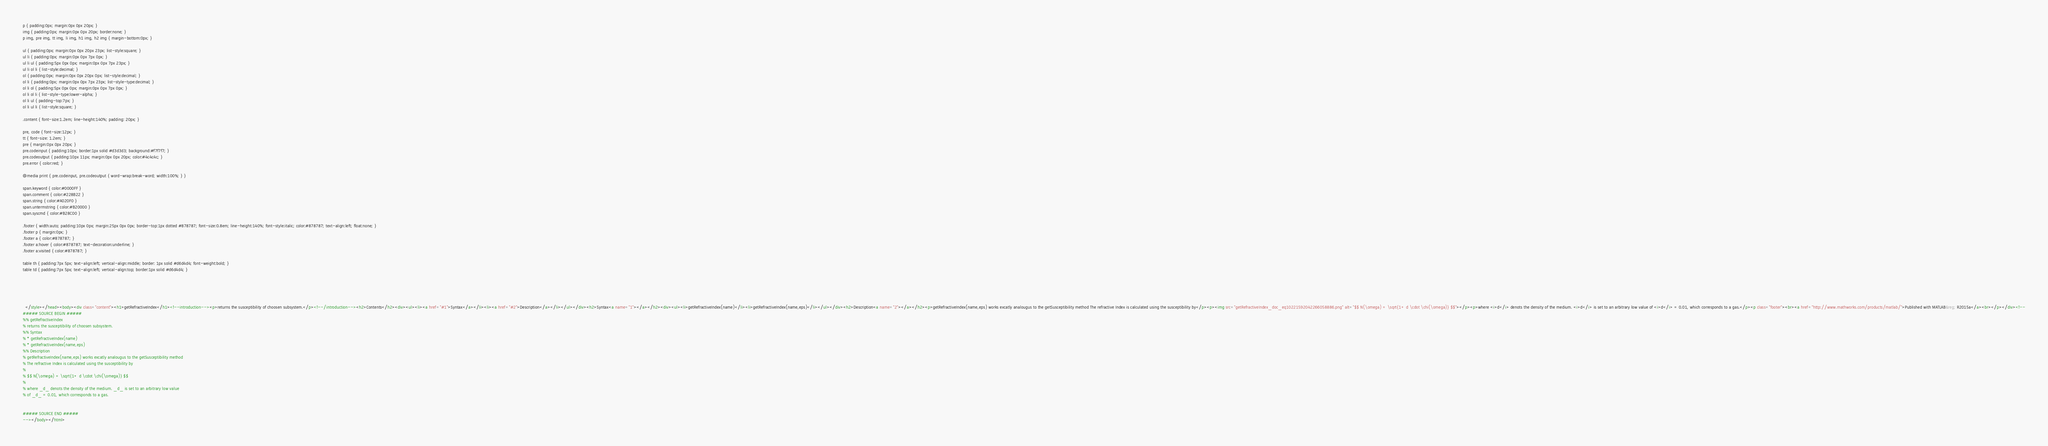<code> <loc_0><loc_0><loc_500><loc_500><_HTML_>p { padding:0px; margin:0px 0px 20px; }
img { padding:0px; margin:0px 0px 20px; border:none; }
p img, pre img, tt img, li img, h1 img, h2 img { margin-bottom:0px; } 

ul { padding:0px; margin:0px 0px 20px 23px; list-style:square; }
ul li { padding:0px; margin:0px 0px 7px 0px; }
ul li ul { padding:5px 0px 0px; margin:0px 0px 7px 23px; }
ul li ol li { list-style:decimal; }
ol { padding:0px; margin:0px 0px 20px 0px; list-style:decimal; }
ol li { padding:0px; margin:0px 0px 7px 23px; list-style-type:decimal; }
ol li ol { padding:5px 0px 0px; margin:0px 0px 7px 0px; }
ol li ol li { list-style-type:lower-alpha; }
ol li ul { padding-top:7px; }
ol li ul li { list-style:square; }

.content { font-size:1.2em; line-height:140%; padding: 20px; }

pre, code { font-size:12px; }
tt { font-size: 1.2em; }
pre { margin:0px 0px 20px; }
pre.codeinput { padding:10px; border:1px solid #d3d3d3; background:#f7f7f7; }
pre.codeoutput { padding:10px 11px; margin:0px 0px 20px; color:#4c4c4c; }
pre.error { color:red; }

@media print { pre.codeinput, pre.codeoutput { word-wrap:break-word; width:100%; } }

span.keyword { color:#0000FF }
span.comment { color:#228B22 }
span.string { color:#A020F0 }
span.untermstring { color:#B20000 }
span.syscmd { color:#B28C00 }

.footer { width:auto; padding:10px 0px; margin:25px 0px 0px; border-top:1px dotted #878787; font-size:0.8em; line-height:140%; font-style:italic; color:#878787; text-align:left; float:none; }
.footer p { margin:0px; }
.footer a { color:#878787; }
.footer a:hover { color:#878787; text-decoration:underline; }
.footer a:visited { color:#878787; }

table th { padding:7px 5px; text-align:left; vertical-align:middle; border: 1px solid #d6d4d4; font-weight:bold; }
table td { padding:7px 5px; text-align:left; vertical-align:top; border:1px solid #d6d4d4; }





  </style></head><body><div class="content"><h1>getRefractiveIndex</h1><!--introduction--><p>returns the susceptibility of choosen subsystem.</p><!--/introduction--><h2>Contents</h2><div><ul><li><a href="#1">Syntax</a></li><li><a href="#2">Description</a></li></ul></div><h2>Syntax<a name="1"></a></h2><div><ul><li>getRefractiveIndex(name)</li><li>getRefractiveIndex(name,eps)</li></ul></div><h2>Description<a name="2"></a></h2><p>getRefractiveIndex(name,eps) works excatly analougus to the getSusceptibility method The refractive Index is calculated using the susceptibility by</p><p><img src="getRefractiveIndex_doc_eq10221592042266058886.png" alt="$$ N(\omega) = \sqrt{1+ d \cdot \chi(\omega)} $$"></p><p>where <i>d</i> denots the density of the medium. <i>d</i> is set to an arbitrary low value of <i>d</i> = 0.01, which corresponds to a gas.</p><p class="footer"><br><a href="http://www.mathworks.com/products/matlab/">Published with MATLAB&reg; R2015a</a><br></p></div><!--
##### SOURCE BEGIN #####
%% getRefractiveIndex
% returns the susceptibility of choosen subsystem.
%% Syntax 
% * getRefractiveIndex(name)
% * getRefractiveIndex(name,eps)
%% Description
% getRefractiveIndex(name,eps) works excatly analougus to the getSusceptibility method
% The refractive Index is calculated using the susceptibility by
% 
% $$ N(\omega) = \sqrt{1+ d \cdot \chi(\omega)} $$
%
% where _d_ denots the density of the medium. _d_ is set to an arbitrary low value 
% of _d_ = 0.01, which corresponds to a gas.


##### SOURCE END #####
--></body></html></code> 